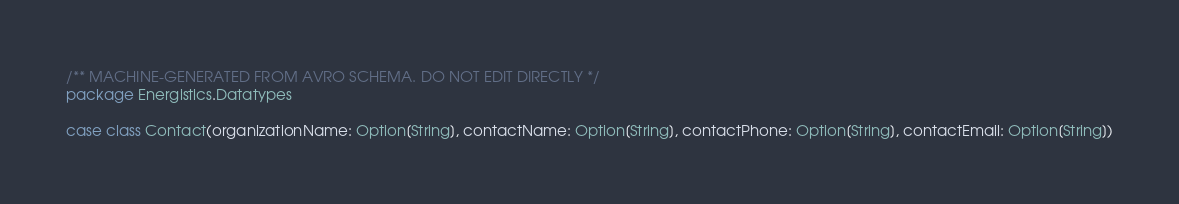Convert code to text. <code><loc_0><loc_0><loc_500><loc_500><_Scala_>/** MACHINE-GENERATED FROM AVRO SCHEMA. DO NOT EDIT DIRECTLY */
package Energistics.Datatypes

case class Contact(organizationName: Option[String], contactName: Option[String], contactPhone: Option[String], contactEmail: Option[String])</code> 